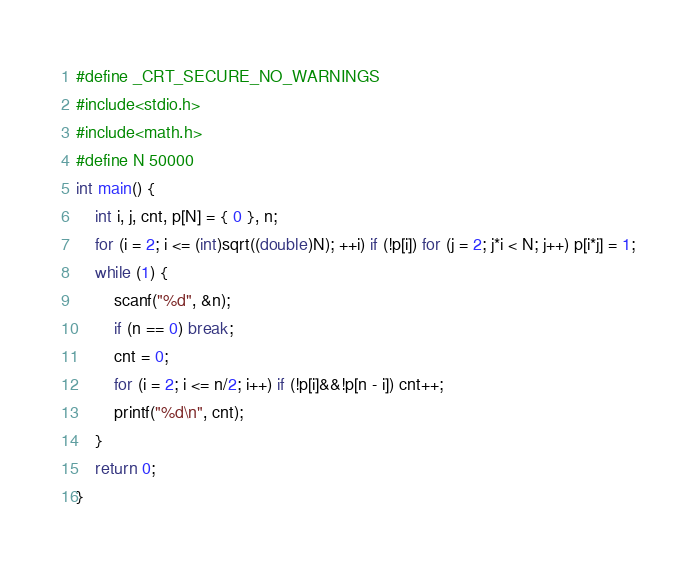<code> <loc_0><loc_0><loc_500><loc_500><_C_>#define _CRT_SECURE_NO_WARNINGS
#include<stdio.h>
#include<math.h>
#define N 50000
int main() {
    int i, j, cnt, p[N] = { 0 }, n;
    for (i = 2; i <= (int)sqrt((double)N); ++i) if (!p[i]) for (j = 2; j*i < N; j++) p[i*j] = 1;
    while (1) {
        scanf("%d", &n);
        if (n == 0) break;
        cnt = 0;
        for (i = 2; i <= n/2; i++) if (!p[i]&&!p[n - i]) cnt++;
        printf("%d\n", cnt);
    }
    return 0;
}</code> 